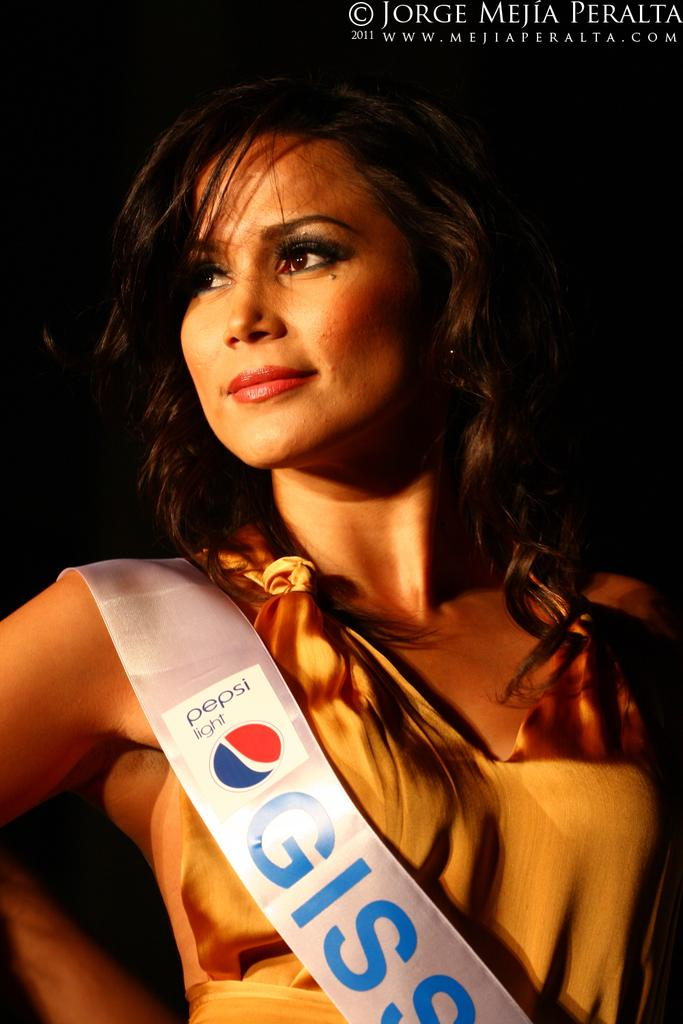Who is the main subject in the image? There is a woman in the image. What is the woman wearing? The woman is wearing a brown dress. What can be observed about the background of the image? The background of the image is dark. What type of blade can be seen in the woman's hand in the image? There is no blade present in the image; the woman is not holding anything in her hand. 